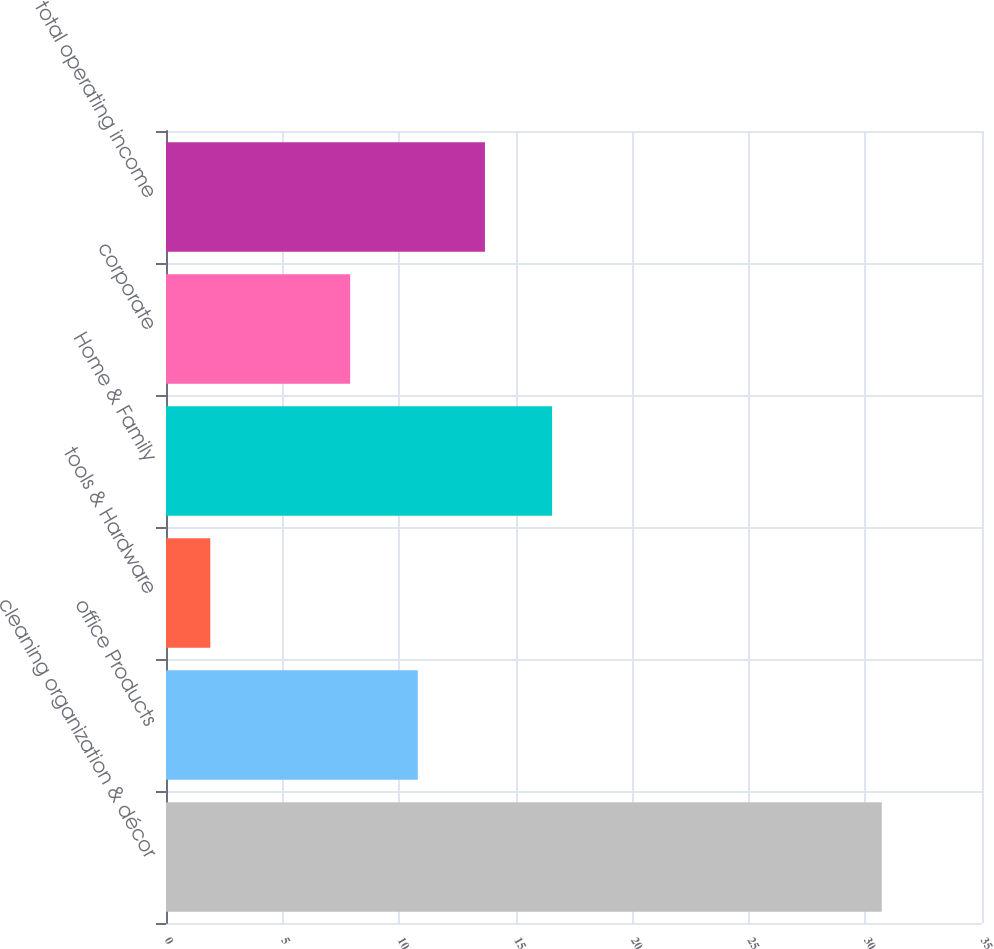<chart> <loc_0><loc_0><loc_500><loc_500><bar_chart><fcel>cleaning organization & décor<fcel>office Products<fcel>tools & Hardware<fcel>Home & Family<fcel>corporate<fcel>total operating income<nl><fcel>30.7<fcel>10.8<fcel>1.9<fcel>16.56<fcel>7.9<fcel>13.68<nl></chart> 